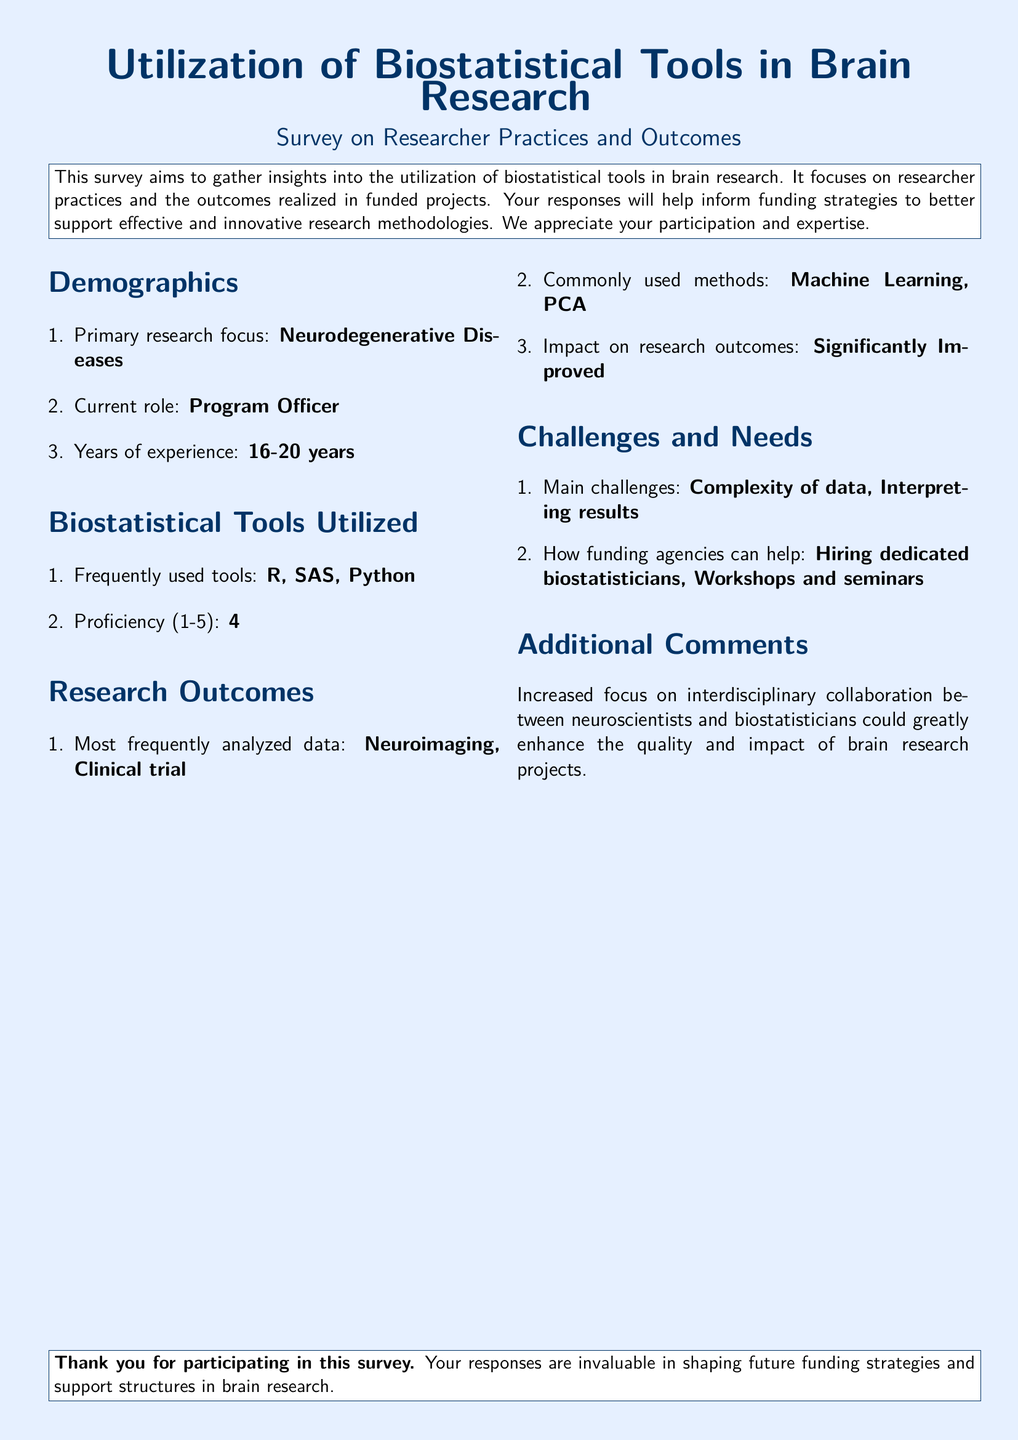what is the primary research focus? The primary research focus is stated explicitly in the document, which is "Neurodegenerative Diseases."
Answer: Neurodegenerative Diseases what tools are frequently used by researchers? The survey lists tools that researchers utilize often, specifically naming "R, SAS, Python."
Answer: R, SAS, Python how many years of experience does the respondent have? The document notes the years of experience as "16-20 years," which indicates the respondent's tenure in the field.
Answer: 16-20 years what is the proficiency level in biostatistical tools? The proficiency level is quantified in the survey as "4" on a scale from 1 to 5, denoting the degree of expertise.
Answer: 4 what is the impact of biostatistical tools on research outcomes? The impact is described as "Significantly Improved," highlighting the effect that these tools have on research results.
Answer: Significantly Improved what are the main challenges faced in brain research? The document outlines main challenges faced by researchers, specifically listing "Complexity of data, Interpreting results."
Answer: Complexity of data, Interpreting results how can funding agencies assist researchers? The responses indicate ways funding agencies could help, which include "Hiring dedicated biostatisticians, Workshops and seminars."
Answer: Hiring dedicated biostatisticians, Workshops and seminars what additional comments are provided regarding collaboration? The additional comments emphasize the need for "interdisciplinary collaboration between neuroscientists and biostatisticians."
Answer: interdisciplinary collaboration between neuroscientists and biostatisticians 